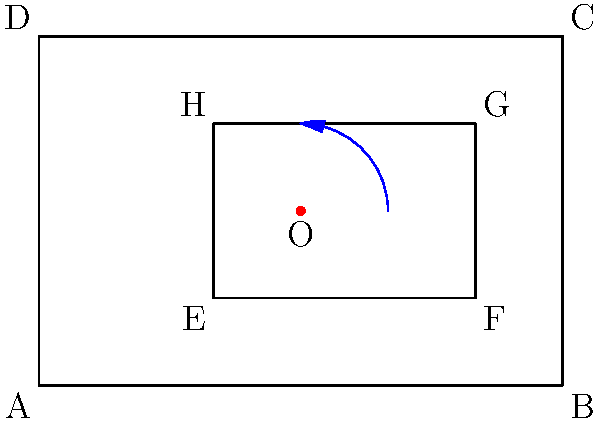A rectangular cargo container (EFGH) needs to be rotated 90° counterclockwise around point O to optimize storage space within a larger rectangular storage area (ABCD). If the dimensions of the cargo container are 3 meters by 2 meters, what will be the coordinates of point F after rotation? To solve this problem, we'll follow these steps:

1) First, identify the initial coordinates of point F:
   F is located at (5,1) in the original position.

2) Identify the center of rotation:
   O is located at (3,2).

3) To rotate a point 90° counterclockwise around a center point, we can use the following formula:
   $$(x', y') = (x_c - (y - y_c), y_c + (x - x_c))$$
   Where $(x,y)$ is the original point, $(x_c,y_c)$ is the center of rotation, and $(x',y')$ is the new point.

4) Plug in the values:
   $x = 5, y = 1, x_c = 3, y_c = 2$

5) Calculate:
   $x' = 3 - (1 - 2) = 3 - (-1) = 4$
   $y' = 2 + (5 - 3) = 2 + 2 = 4$

6) Therefore, after rotation, point F will be at (4,4).
Answer: (4,4) 